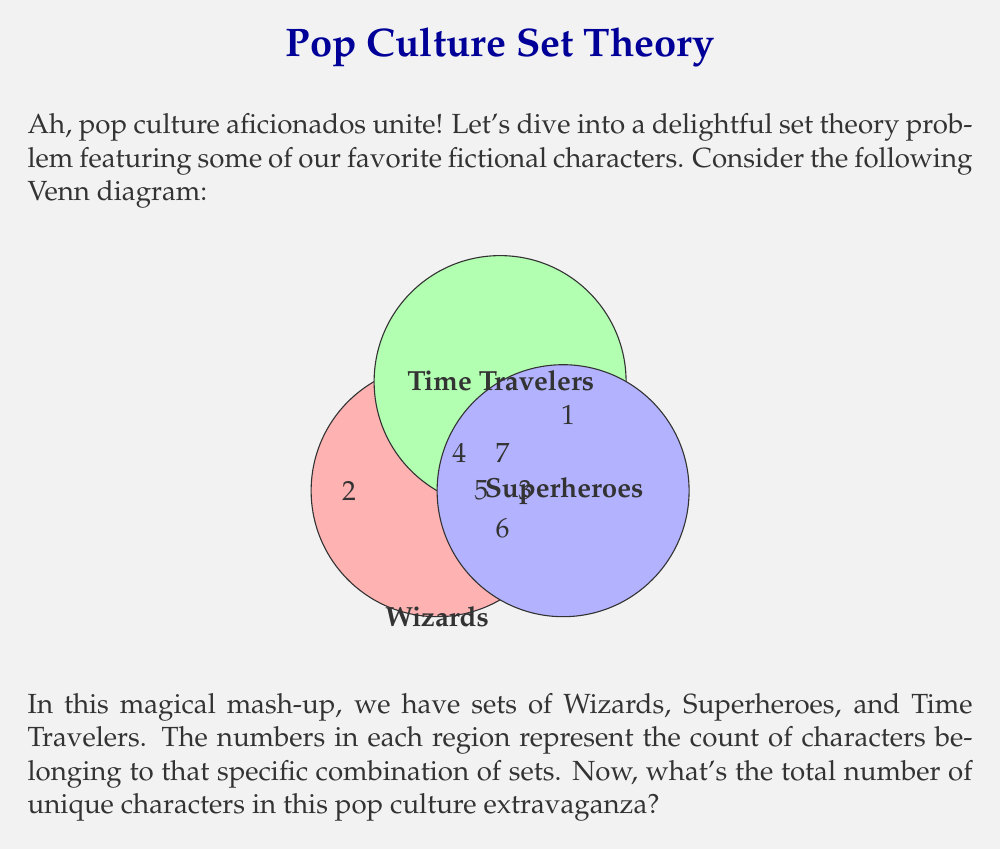Could you help me with this problem? Let's break this down step-by-step, shall we? It's like assembling our own super-team of fictional characters!

1) First, let's identify what each region represents:
   - 2: Wizards only
   - 3: Superheroes only
   - 1: Time Travelers only
   - 4: Wizards and Time Travelers
   - 5: Superheroes and Time Travelers
   - 6: Wizards and Superheroes
   - 7: Wizards, Superheroes, and Time Travelers

2) Now, let's use the principle of inclusion-exclusion to find the total number of elements. The formula for three sets A, B, and C is:

   $$|A \cup B \cup C| = |A| + |B| + |C| - |A \cap B| - |A \cap C| - |B \cap C| + |A \cap B \cap C|$$

3) Let's calculate each term:
   - $|A|$ (Wizards) = 2 + 4 + 6 + 7 = 19
   - $|B|$ (Superheroes) = 3 + 5 + 6 + 7 = 21
   - $|C|$ (Time Travelers) = 1 + 4 + 5 + 7 = 17
   - $|A \cap B|$ (Wizards and Superheroes) = 6 + 7 = 13
   - $|A \cap C|$ (Wizards and Time Travelers) = 4 + 7 = 11
   - $|B \cap C|$ (Superheroes and Time Travelers) = 5 + 7 = 12
   - $|A \cap B \cap C|$ (All three) = 7

4) Now, let's plug these values into our formula:

   $$|A \cup B \cup C| = 19 + 21 + 17 - 13 - 11 - 12 + 7 = 28$$

And there we have it! Our pop culture universe contains 28 unique characters. What a crowd!
Answer: 28 